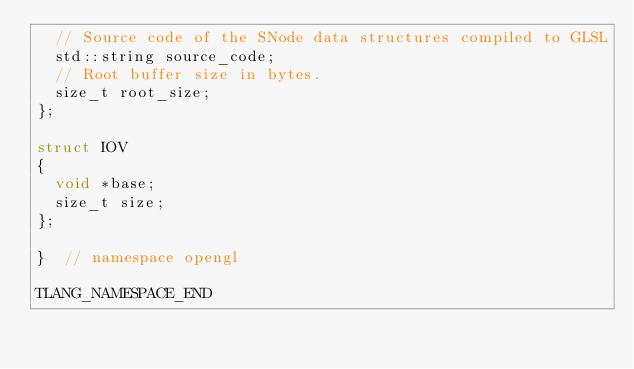<code> <loc_0><loc_0><loc_500><loc_500><_C_>  // Source code of the SNode data structures compiled to GLSL
  std::string source_code;
  // Root buffer size in bytes.
  size_t root_size;
};

struct IOV
{
  void *base;
  size_t size;
};

}  // namespace opengl

TLANG_NAMESPACE_END
</code> 